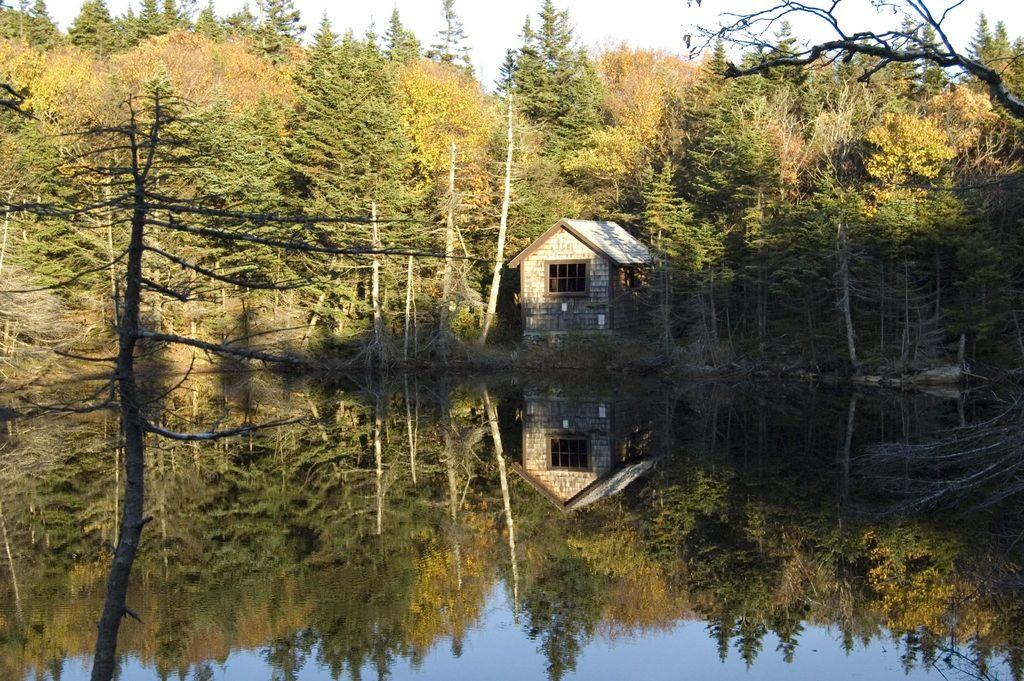What is present at the bottom of the image? There is water at the bottom of the image. What can be seen in the background of the image? There are trees in the background of the image. What type of structure is visible in the image? There is a house in the image. What is visible at the top of the image? The sky is visible at the top of the image. How many beds are visible in the image? There are no beds present in the image. What type of voyage is depicted in the image? There is no voyage depicted in the image; it features water, trees, a house, and the sky. 